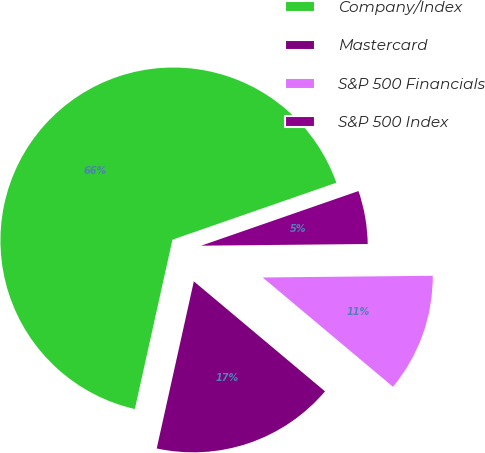<chart> <loc_0><loc_0><loc_500><loc_500><pie_chart><fcel>Company/Index<fcel>Mastercard<fcel>S&P 500 Financials<fcel>S&P 500 Index<nl><fcel>66.2%<fcel>17.37%<fcel>11.27%<fcel>5.16%<nl></chart> 